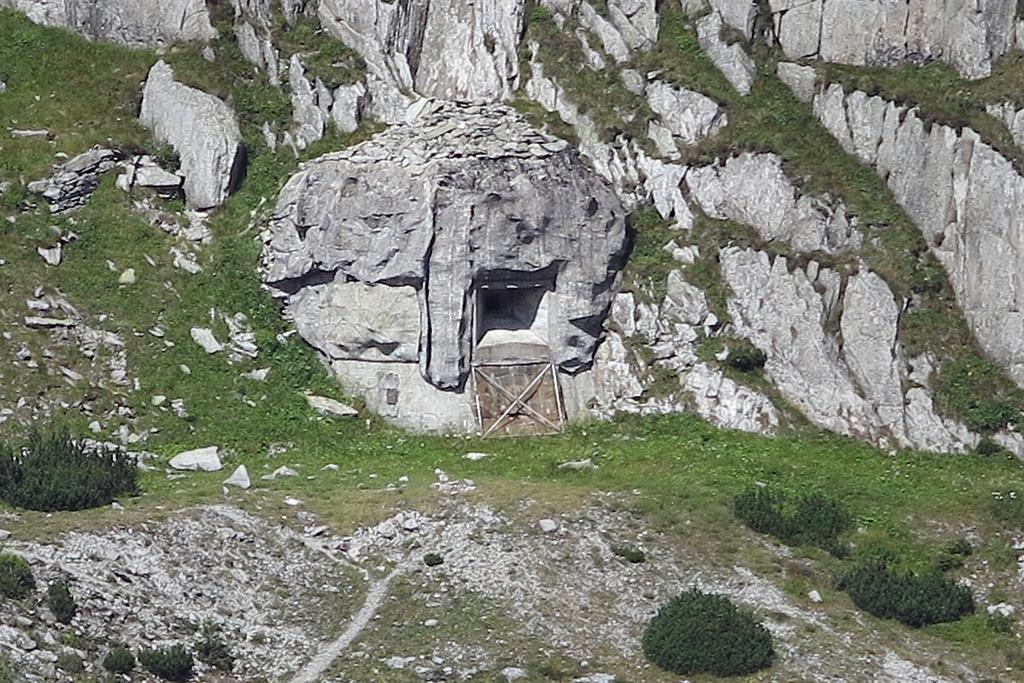What is the primary feature of the landscape in the image? There are many rocks in the image. What type of terrain is visible in the image? There is a grassy land in the image. What kind of object can be seen made of wood? There is a wooden object in the image. How many plants are present in the image? There are few plants in the image. Can you tell me what the argument is about between the two visitors in the image? There are no visitors present in the image, and therefore no argument can be observed. 